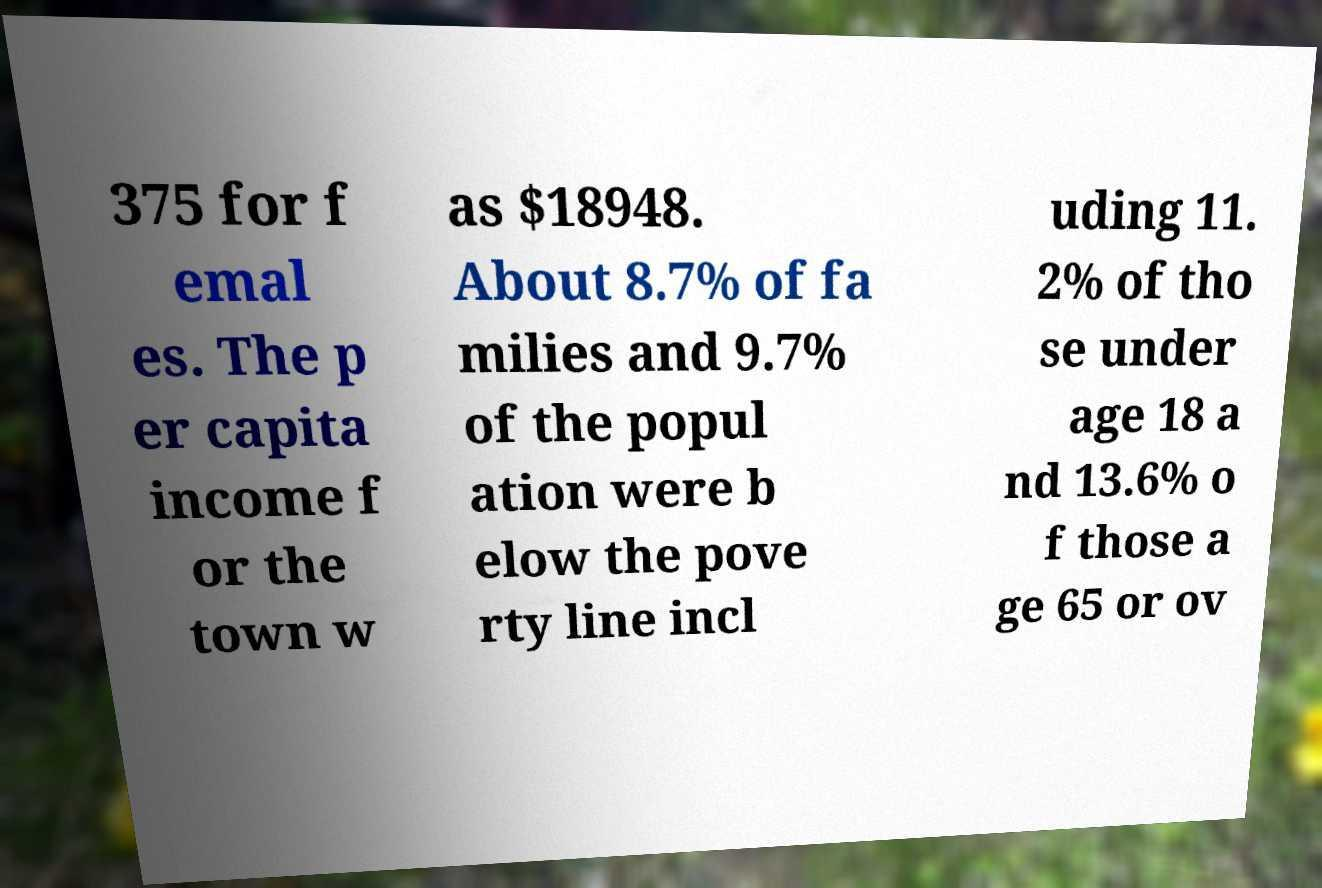Please read and relay the text visible in this image. What does it say? 375 for f emal es. The p er capita income f or the town w as $18948. About 8.7% of fa milies and 9.7% of the popul ation were b elow the pove rty line incl uding 11. 2% of tho se under age 18 a nd 13.6% o f those a ge 65 or ov 